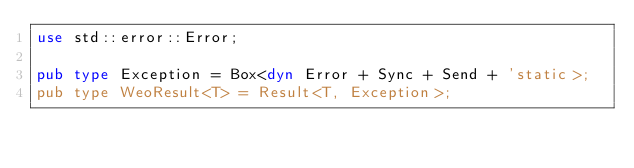Convert code to text. <code><loc_0><loc_0><loc_500><loc_500><_Rust_>use std::error::Error;

pub type Exception = Box<dyn Error + Sync + Send + 'static>;
pub type WeoResult<T> = Result<T, Exception>;
</code> 